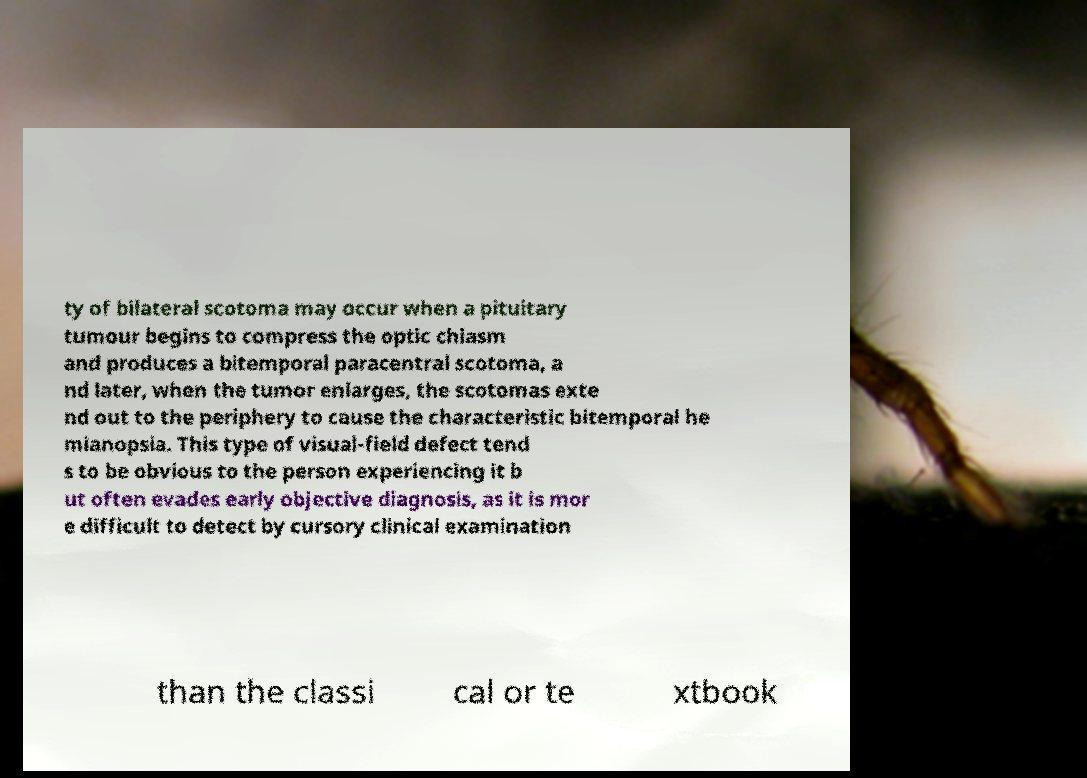Please read and relay the text visible in this image. What does it say? ty of bilateral scotoma may occur when a pituitary tumour begins to compress the optic chiasm and produces a bitemporal paracentral scotoma, a nd later, when the tumor enlarges, the scotomas exte nd out to the periphery to cause the characteristic bitemporal he mianopsia. This type of visual-field defect tend s to be obvious to the person experiencing it b ut often evades early objective diagnosis, as it is mor e difficult to detect by cursory clinical examination than the classi cal or te xtbook 